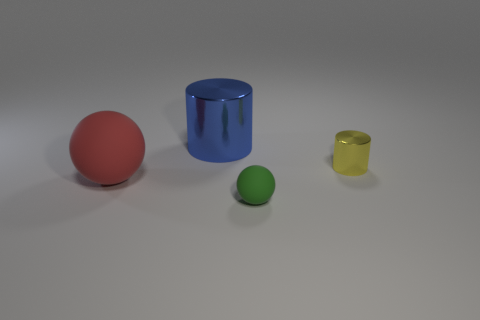Add 4 big red shiny blocks. How many objects exist? 8 Subtract all metal cylinders. Subtract all small yellow cylinders. How many objects are left? 1 Add 4 red matte things. How many red matte things are left? 5 Add 1 yellow rubber spheres. How many yellow rubber spheres exist? 1 Subtract 0 cyan blocks. How many objects are left? 4 